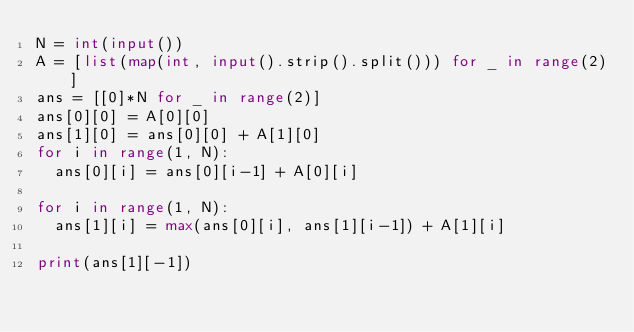<code> <loc_0><loc_0><loc_500><loc_500><_Python_>N = int(input())
A = [list(map(int, input().strip().split())) for _ in range(2)]
ans = [[0]*N for _ in range(2)]
ans[0][0] = A[0][0]
ans[1][0] = ans[0][0] + A[1][0]
for i in range(1, N):
  ans[0][i] = ans[0][i-1] + A[0][i]

for i in range(1, N):
  ans[1][i] = max(ans[0][i], ans[1][i-1]) + A[1][i]

print(ans[1][-1])
</code> 